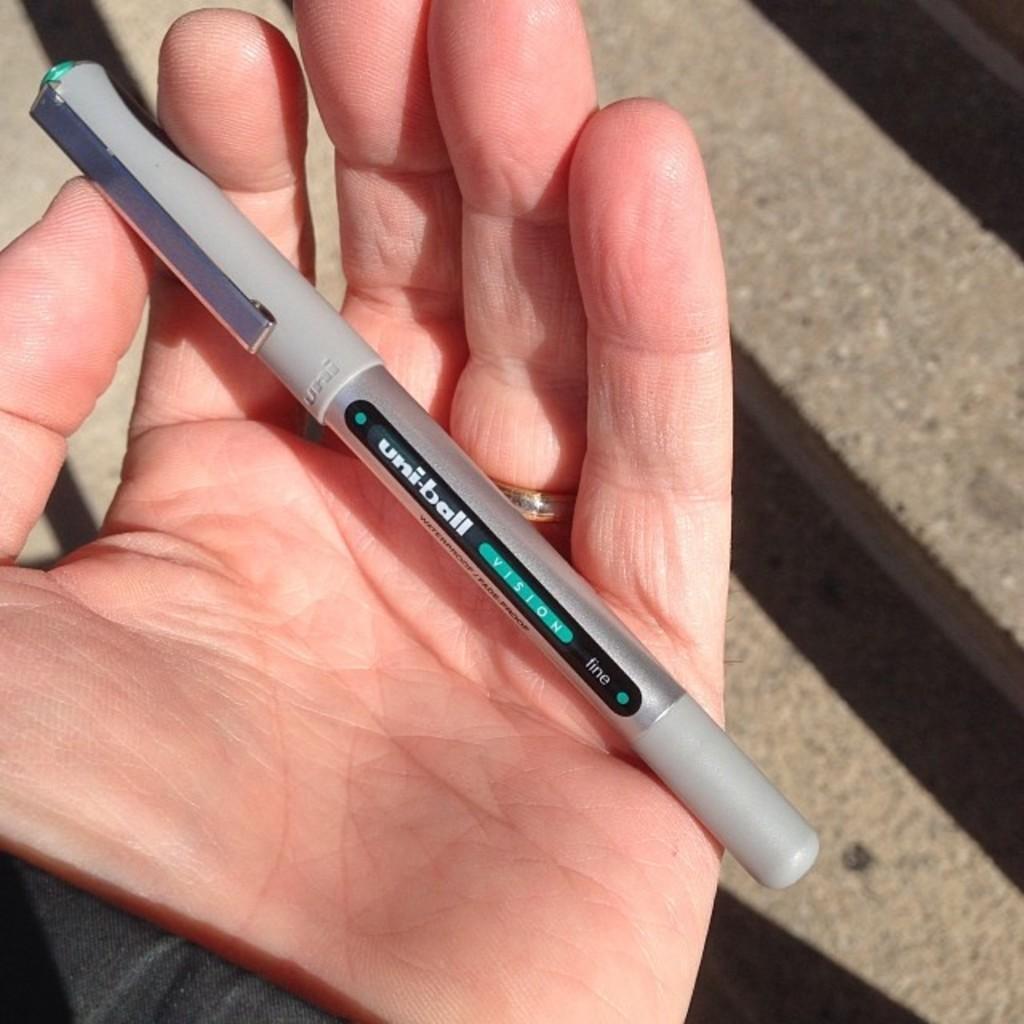Please provide a concise description of this image. A human hand is holding a pen. 